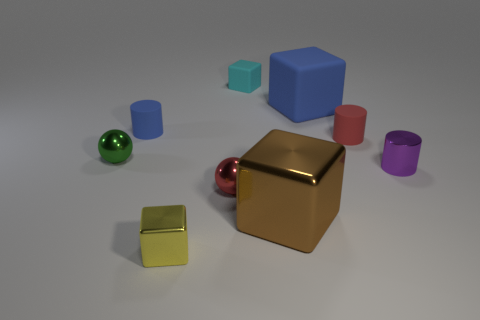Subtract 1 cubes. How many cubes are left? 3 Subtract all blocks. How many objects are left? 5 Subtract all tiny yellow metallic blocks. Subtract all brown metallic objects. How many objects are left? 7 Add 6 red cylinders. How many red cylinders are left? 7 Add 5 green things. How many green things exist? 6 Subtract 0 gray cubes. How many objects are left? 9 